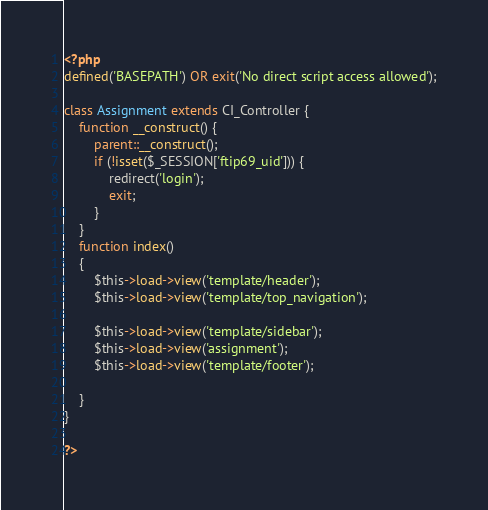Convert code to text. <code><loc_0><loc_0><loc_500><loc_500><_PHP_><?php
defined('BASEPATH') OR exit('No direct script access allowed');

class Assignment extends CI_Controller {
	function __construct() {
        parent::__construct();
		if (!isset($_SESSION['ftip69_uid'])) {
			redirect('login');
			exit;
		}
	}
	function index()
	{
		$this->load->view('template/header');
		$this->load->view('template/top_navigation');
		
		$this->load->view('template/sidebar');
		$this->load->view('assignment');
		$this->load->view('template/footer');
		
	}
}

?></code> 